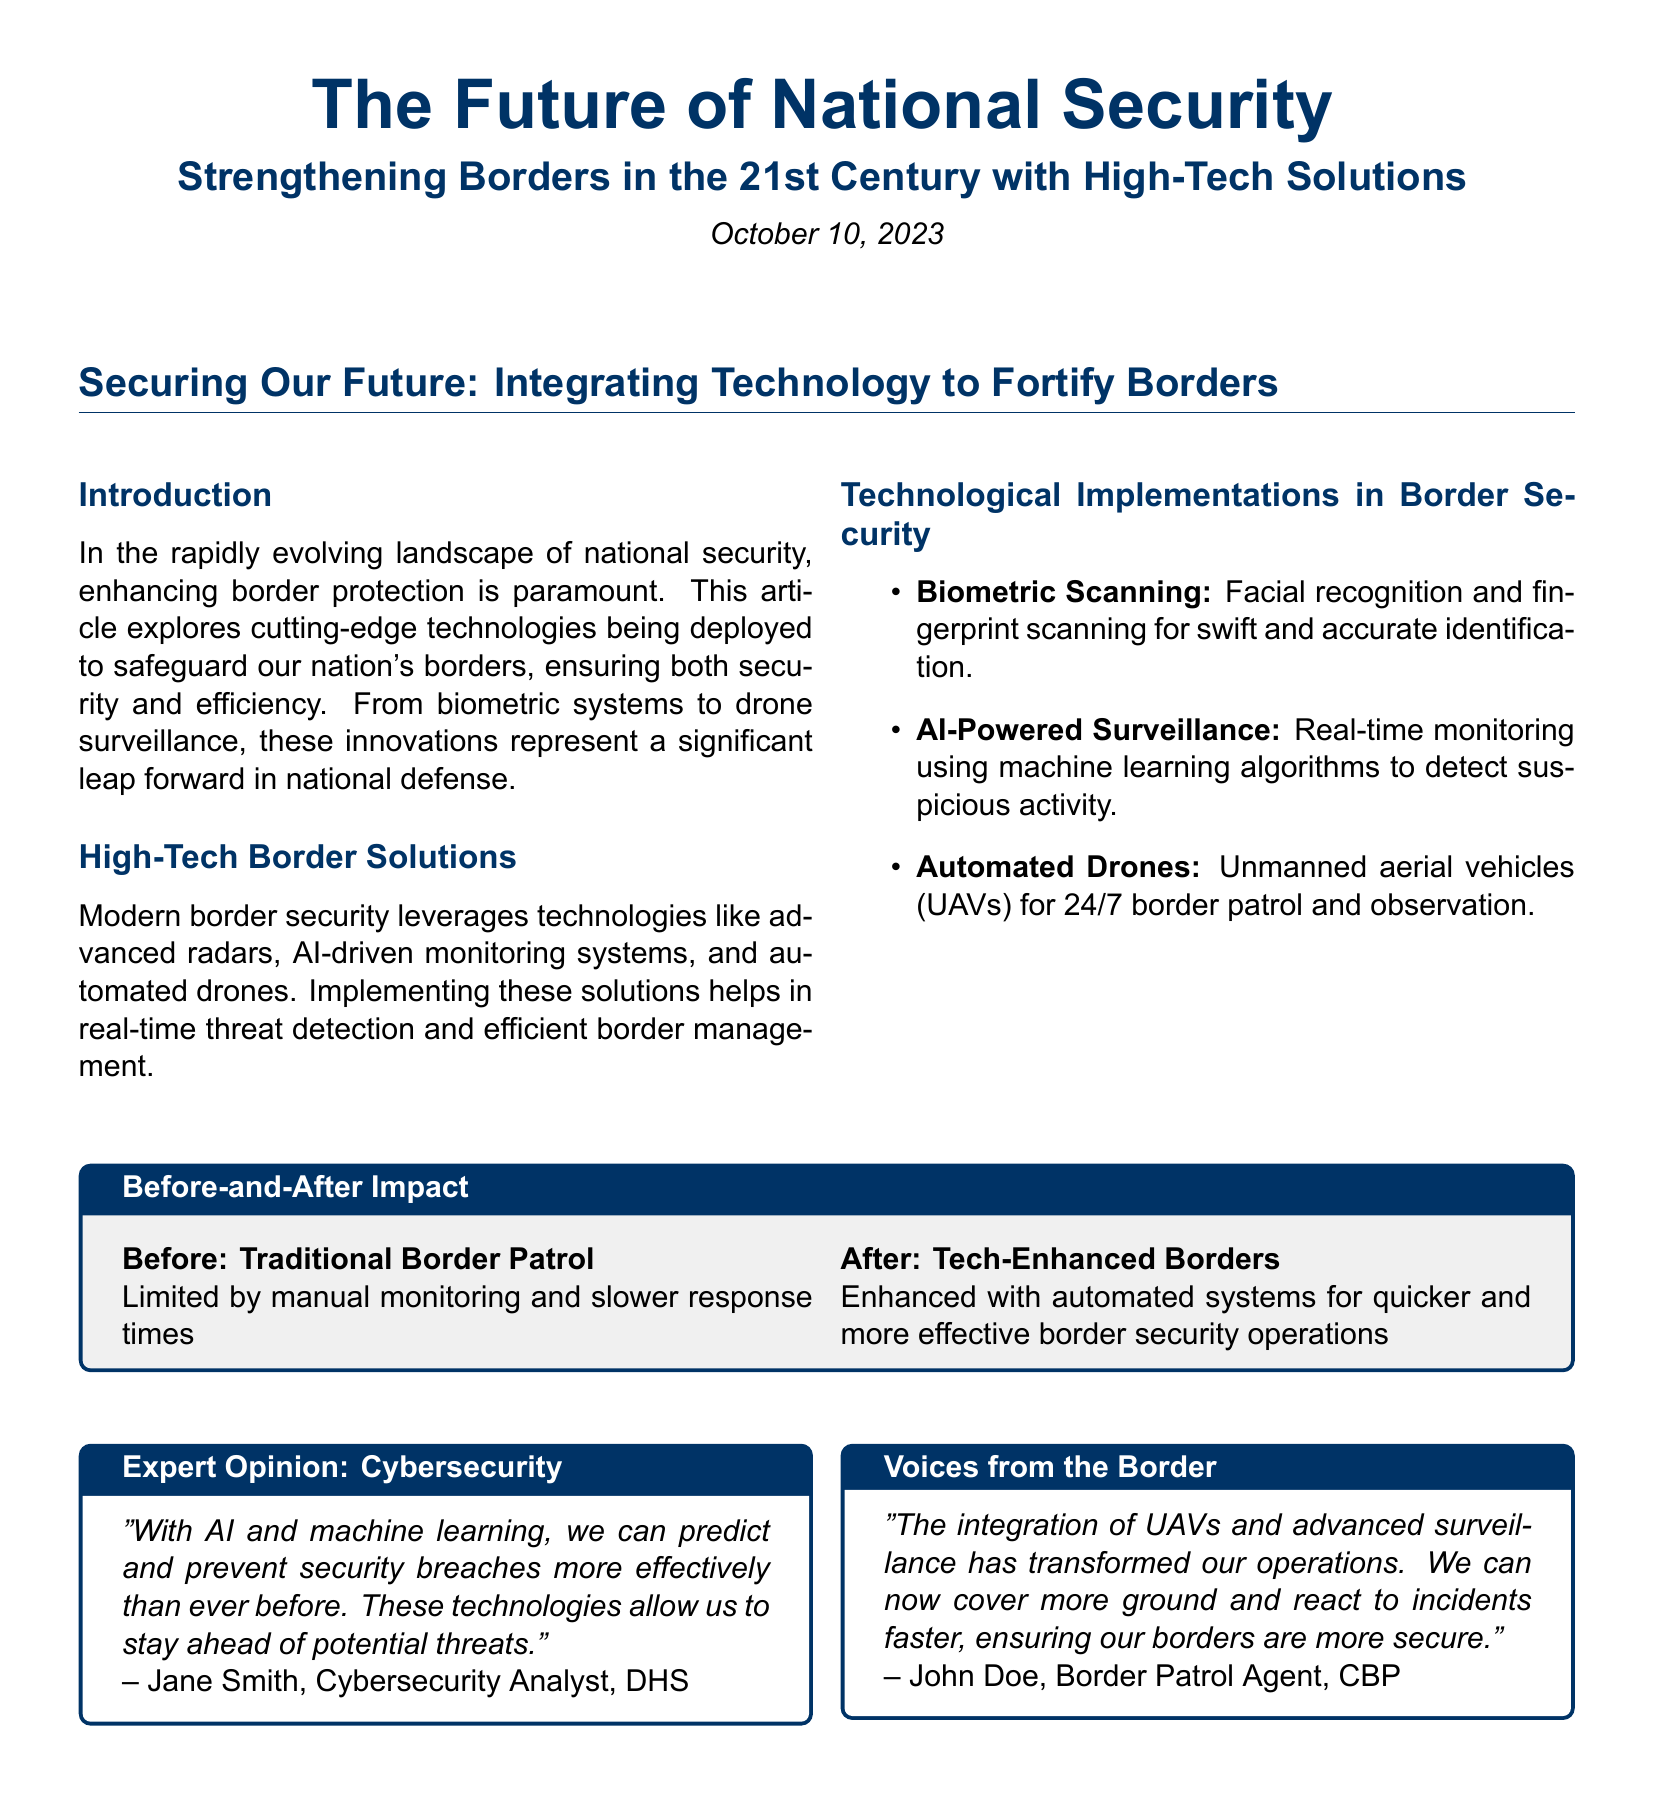What is the date of publication? The date of publication is found in the article header, showing when the article was released.
Answer: October 10, 2023 What technology is used for swift and accurate identification? The document mentions specific technologies utilized in border security, including biometric systems.
Answer: Biometric Scanning Who is the Cybersecurity Analyst mentioned in the document? The article includes quotes from expert opinions, one of which attributes a quote to a specific individual.
Answer: Jane Smith What type of vehicles are used for 24/7 border patrol? The text describes specific technology implementations, including unmanned aerial vehicles for monitoring.
Answer: Automated Drones What did the border patrol agent say has transformed their operations? The sidebar interview from the border patrol agent highlights advancements that have improved their work efficiency.
Answer: Integration of UAVs and advanced surveillance What significant benefit is mentioned regarding tech-enhanced borders? The document compares traditional and tech-enhanced border security, noting improvements that come with technology.
Answer: Quicker and more effective operations What kind of algorithms are mentioned for real-time monitoring? The technologies listed in the document include AI-driven methods for detection and analysis.
Answer: Machine learning algorithms What does the article identify as a key priority for national security? The introduction discusses overarching themes regarding border protection in the context of evolving national security.
Answer: Enhancing border protection 